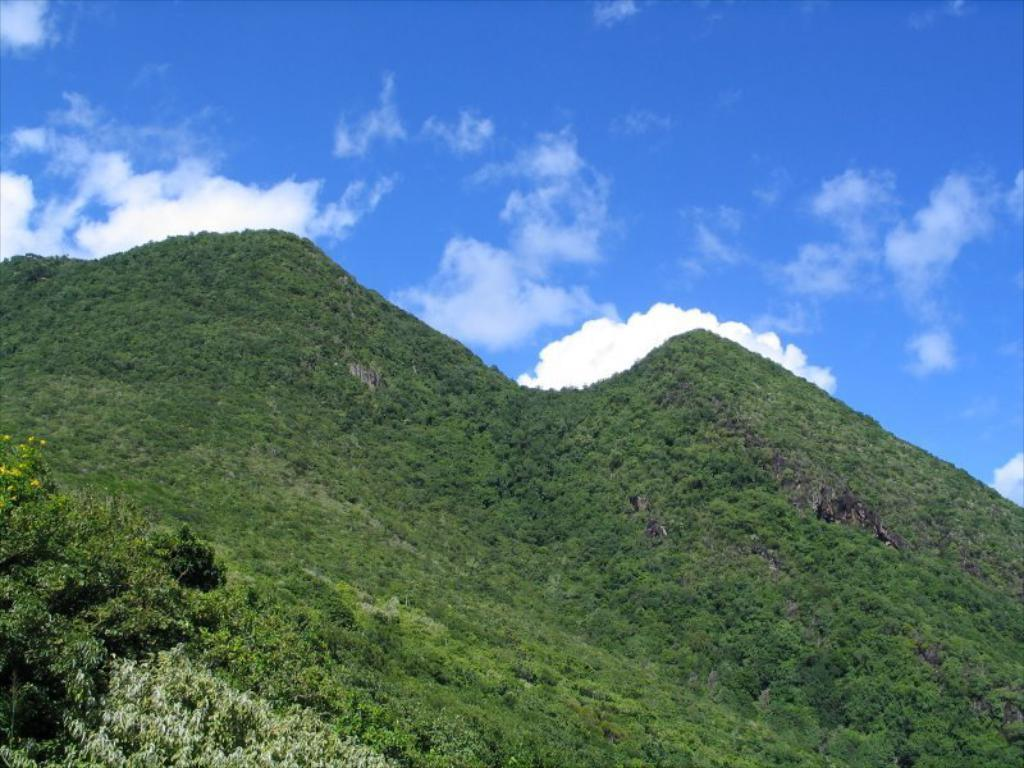What type of scenery is depicted in the image? The image contains a mountain scenery. What can be observed on the surface of the mountains? The mountain scenery includes a green surface. What color is the sky in the image? The sky in the image is blue. What type of stitch is used to create the mountain scenery in the image? The image is not a stitched piece of fabric, so there is no stitch used to create the mountain scenery. What sound can be heard coming from the mountains in the image? There is no sound present in the image, as it is a static picture. 